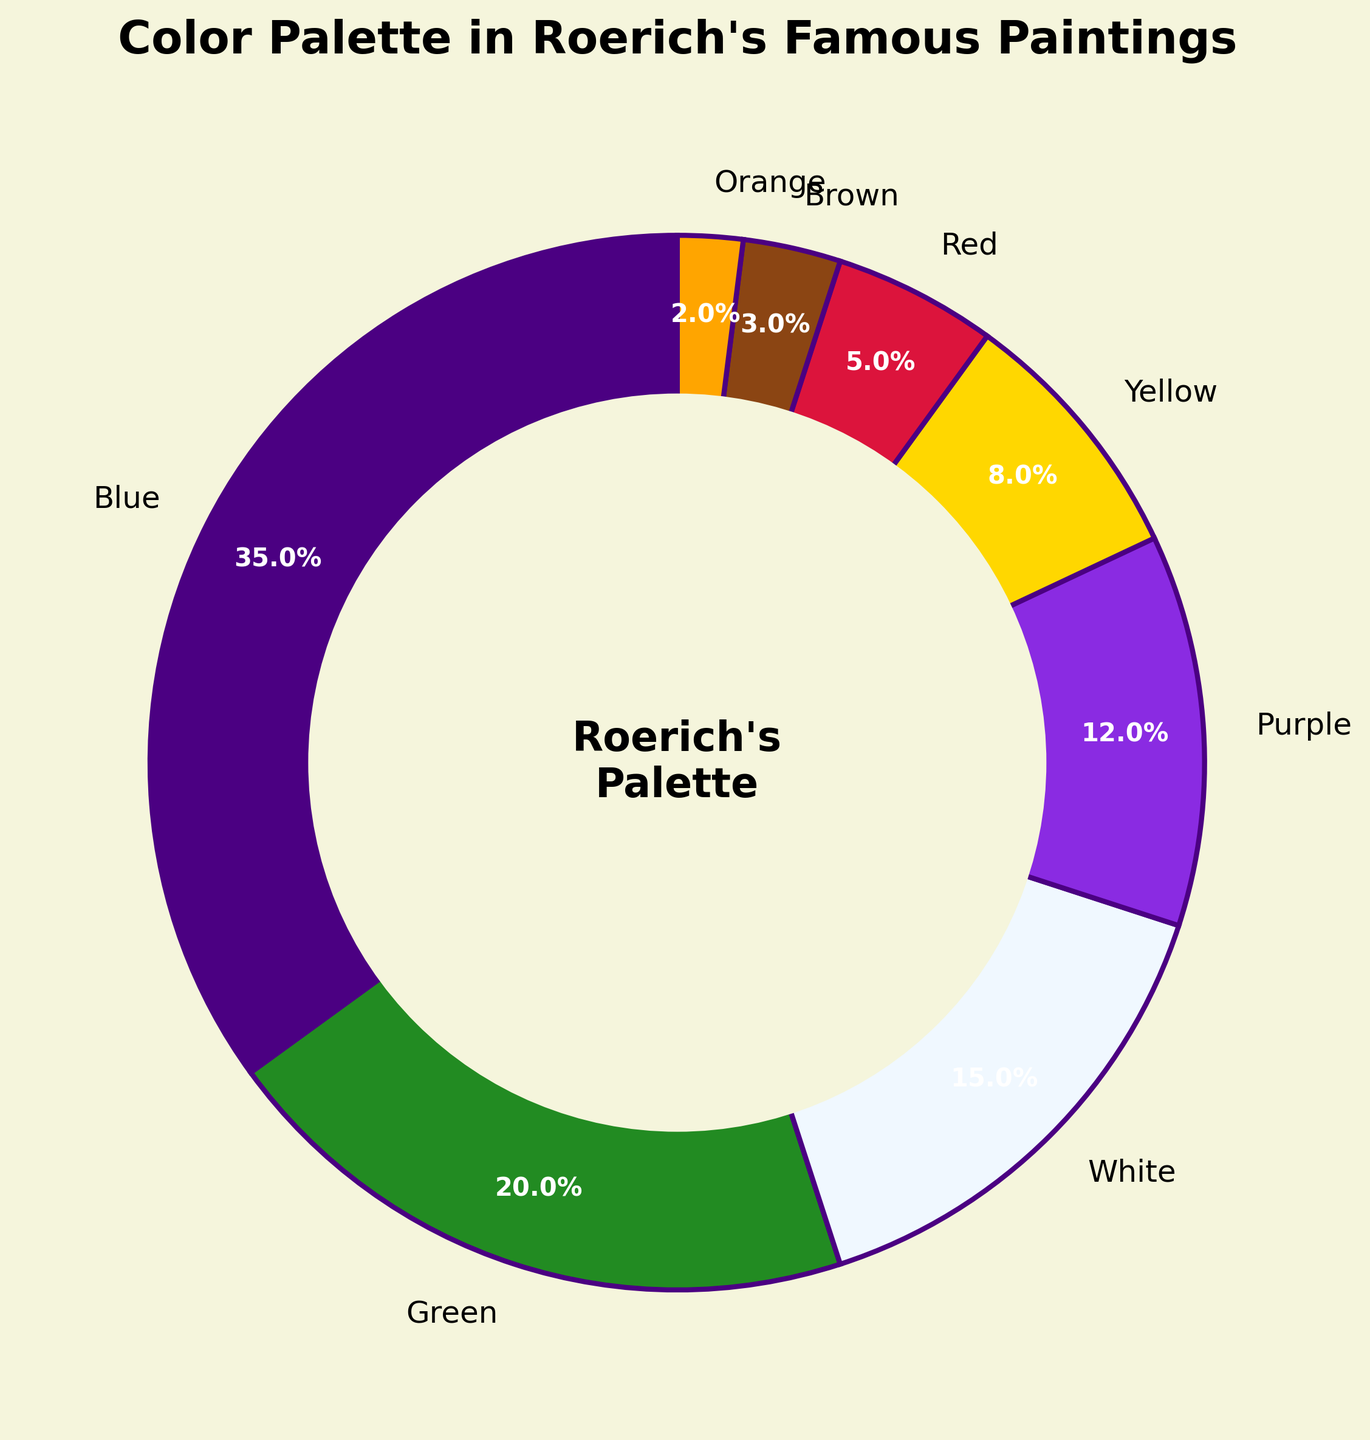Which color is the most prominent in Roerich's paintings? The pie chart shows the percentage use of different colors, and the largest segment corresponds to blue, which has the highest percentage of 35%.
Answer: Blue What percentage of Roerich's color palette is made up by green and white combined? The pie chart lists green at 20% and white at 15%. To find the combined percentage, add 20% + 15% = 35%.
Answer: 35% Is yellow used more or less frequently than red in Roerich's paintings? The pie chart shows that yellow makes up 8% of the palette, while red makes up 5%. Since 8% is greater than 5%, yellow is used more frequently than red.
Answer: More Which two colors together account for the smallest percentage in Roerich's color palette? Reviewing the percentages, the smallest individual contributions are from orange (2%) and brown (3%). Adding them together gives 2% + 3% = 5%.
Answer: Orange and brown How does the usage of purple compare to that of white in terms of percentage? The pie chart indicates that purple accounts for 12% of the palette, whereas white accounts for 15%. Because 15% is greater than 12%, white is used more than purple.
Answer: White more than purple What is the difference in percentage points between the most and least used colors? The most used color is blue at 35%, and the least used color is orange at 2%. The difference is 35% - 2% = 33%.
Answer: 33% Which two colors combined make up the same proportion of the palette as blue alone? Blue alone accounts for 35%. Checking combinations, green (20%) and white (15%) together make 20% + 15% = 35%, matching the proportion of blue alone.
Answer: Green and white What is the total percentage of Roerich's palette that consists of warm colors (red, yellow, orange, brown)? Summing the percentages for red, yellow, orange, and brown: 5% + 8% + 2% + 3% = 18%.
Answer: 18% If you were to create a pie chart where blue and green are combined into one category, what percentage would this new category represent? Blue is 35% and green is 20%. Adding them gives 35% + 20% = 55%.
Answer: 55% Which color would fit into a category named 'Others' if it includes all colors that together make up 10% or less of the total palette? According to the pie chart, brown (3%) and orange (2%) each individually contribute 10% or less and total 3% + 2% = 5%, fitting into the 'Others' category.
Answer: Brown and orange 